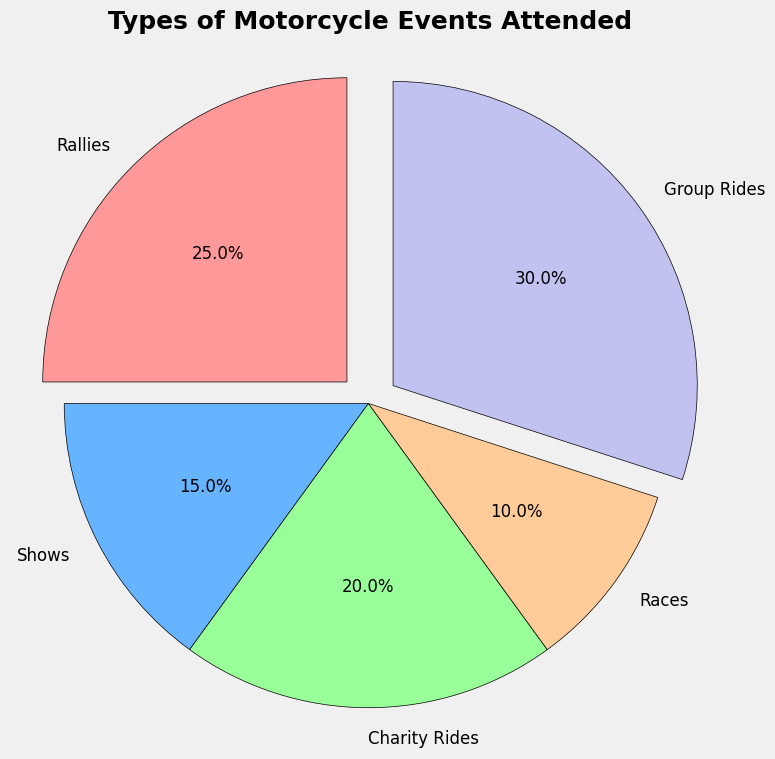What types of motorcycle events are represented in the pie chart? The pie chart includes five different types of motorcycle events: Rallies, Shows, Charity Rides, Races, and Group Rides, each represented by a different section of the pie.
Answer: Rallies, Shows, Charity Rides, Races, Group Rides Which event type has the largest share of the pie chart? By looking at the size of the segments, it is clear that Group Rides take up the largest share of the pie chart, as it visually occupies the most space.
Answer: Group Rides What percentage of the total events is made up by Charity Rides and Races combined? Charity Rides occupy 20% and Races occupy 10% of the pie chart. Combining these, we get 20% + 10% = 30%.
Answer: 30% Which two event types together make up more than 50% of the pie chart? Group Rides (30%) and Rallies (25%) combined make up 55% of the pie chart (30% + 25%).
Answer: Group Rides and Rallies How does the proportion of Rallies compare to Shows? Rallies account for 25% of the pie chart while Shows account for 15%. This means Rallies have a higher proportion compared to Shows.
Answer: Rallies have a higher proportion What is the difference in percentage points between the largest and smallest segments? The largest segment is Group Rides at 30%, and the smallest segment is Races at 10%. The difference in percentage points is 30% - 10% = 20%.
Answer: 20% Which event types are highlighted in the pie chart and why might they be emphasized? Group Rides and Rallies are both slightly exploded out of the pie chart. This could be to emphasize their significance or to highlight that these are the top two most attended event types.
Answer: Group Rides and Rallies If another event type with 20 data points were included, how would the percentages for each event type change? Currently, there are 100 data points. Adding another event type with 20 data points would make it 120 total. Each event type's percentage would need to be recalculated: 
- Rallies: (25/120) * 100 = 20.83%
- Shows: (15/120) * 100 = 12.5%
- Charity Rides: (20/120) * 100 = 16.67%
- Races: (10/120) * 100 = 8.33%
- Group Rides: (30/120) * 100 = 25%
- New event: (20/120) * 100 = 16.67%
Answer: Adjusted percentages as explained 